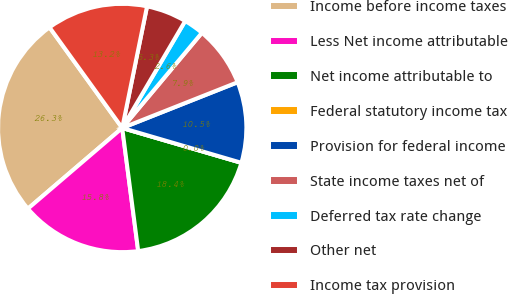Convert chart to OTSL. <chart><loc_0><loc_0><loc_500><loc_500><pie_chart><fcel>Income before income taxes<fcel>Less Net income attributable<fcel>Net income attributable to<fcel>Federal statutory income tax<fcel>Provision for federal income<fcel>State income taxes net of<fcel>Deferred tax rate change<fcel>Other net<fcel>Income tax provision<nl><fcel>26.31%<fcel>15.79%<fcel>18.42%<fcel>0.0%<fcel>10.53%<fcel>7.9%<fcel>2.63%<fcel>5.26%<fcel>13.16%<nl></chart> 